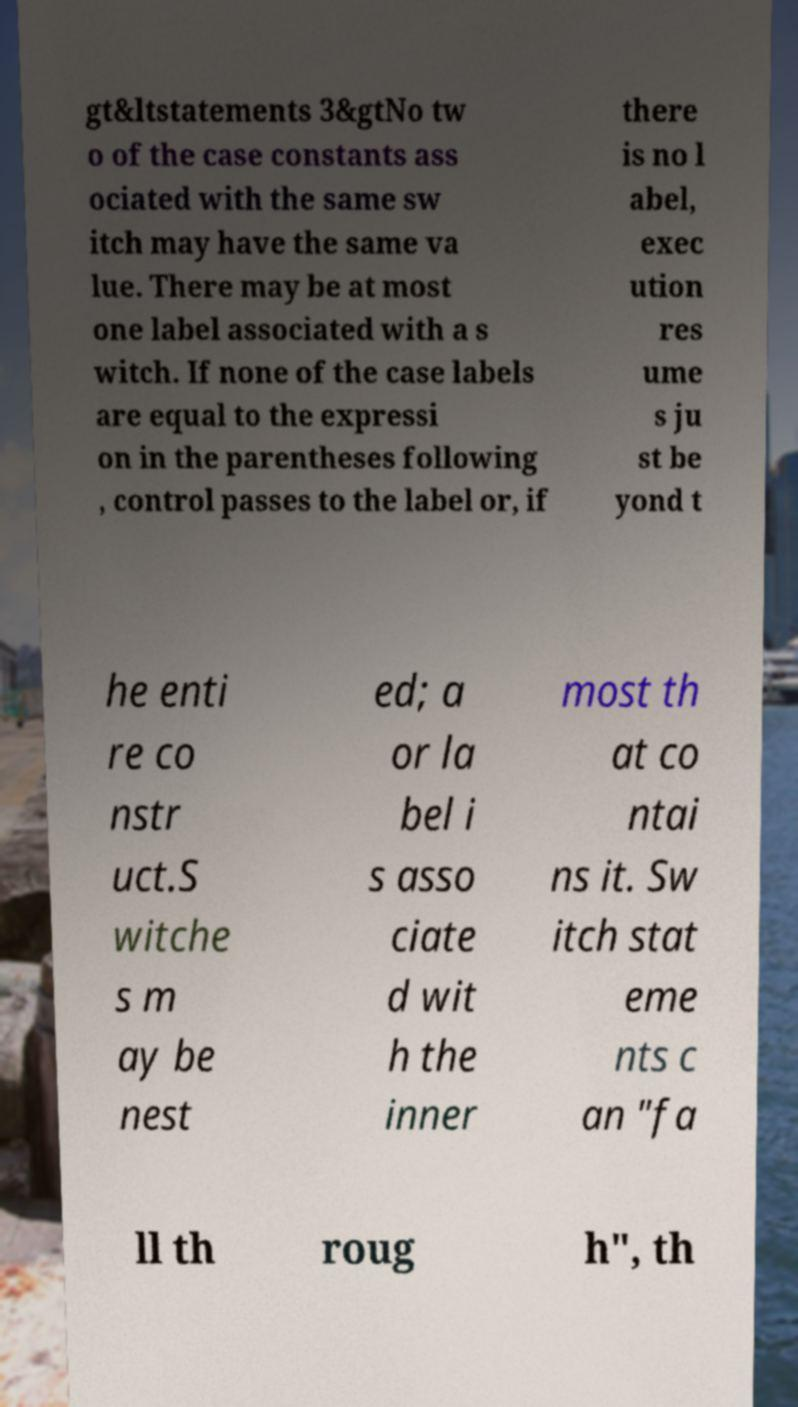I need the written content from this picture converted into text. Can you do that? gt&ltstatements 3&gtNo tw o of the case constants ass ociated with the same sw itch may have the same va lue. There may be at most one label associated with a s witch. If none of the case labels are equal to the expressi on in the parentheses following , control passes to the label or, if there is no l abel, exec ution res ume s ju st be yond t he enti re co nstr uct.S witche s m ay be nest ed; a or la bel i s asso ciate d wit h the inner most th at co ntai ns it. Sw itch stat eme nts c an "fa ll th roug h", th 